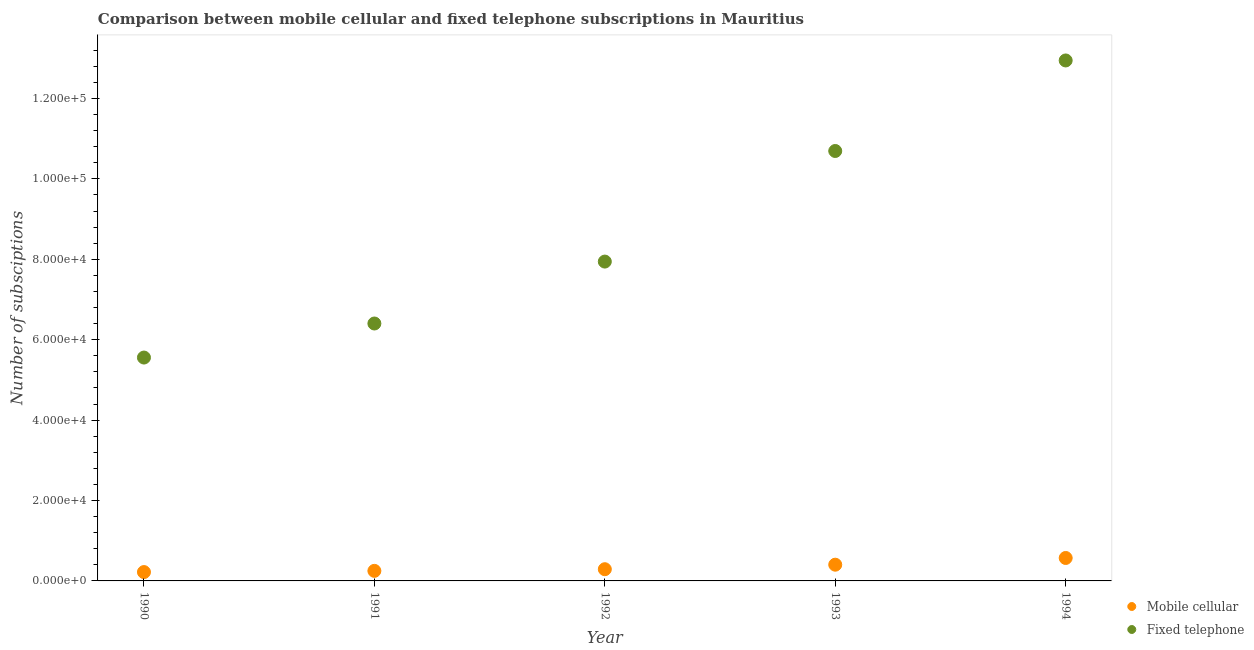How many different coloured dotlines are there?
Ensure brevity in your answer.  2. What is the number of mobile cellular subscriptions in 1993?
Provide a succinct answer. 4037. Across all years, what is the maximum number of fixed telephone subscriptions?
Your response must be concise. 1.29e+05. Across all years, what is the minimum number of fixed telephone subscriptions?
Offer a terse response. 5.56e+04. In which year was the number of fixed telephone subscriptions minimum?
Your response must be concise. 1990. What is the total number of fixed telephone subscriptions in the graph?
Make the answer very short. 4.35e+05. What is the difference between the number of fixed telephone subscriptions in 1990 and that in 1992?
Your answer should be compact. -2.39e+04. What is the difference between the number of mobile cellular subscriptions in 1993 and the number of fixed telephone subscriptions in 1991?
Ensure brevity in your answer.  -6.00e+04. What is the average number of fixed telephone subscriptions per year?
Provide a short and direct response. 8.71e+04. In the year 1993, what is the difference between the number of mobile cellular subscriptions and number of fixed telephone subscriptions?
Your answer should be compact. -1.03e+05. What is the ratio of the number of fixed telephone subscriptions in 1991 to that in 1993?
Give a very brief answer. 0.6. Is the number of fixed telephone subscriptions in 1990 less than that in 1993?
Your answer should be compact. Yes. What is the difference between the highest and the second highest number of mobile cellular subscriptions?
Give a very brief answer. 1669. What is the difference between the highest and the lowest number of mobile cellular subscriptions?
Ensure brevity in your answer.  3506. Is the sum of the number of fixed telephone subscriptions in 1992 and 1993 greater than the maximum number of mobile cellular subscriptions across all years?
Your answer should be compact. Yes. Is the number of mobile cellular subscriptions strictly greater than the number of fixed telephone subscriptions over the years?
Give a very brief answer. No. Is the number of fixed telephone subscriptions strictly less than the number of mobile cellular subscriptions over the years?
Offer a terse response. No. How many dotlines are there?
Give a very brief answer. 2. How many years are there in the graph?
Your answer should be very brief. 5. Does the graph contain grids?
Offer a very short reply. No. How many legend labels are there?
Give a very brief answer. 2. How are the legend labels stacked?
Provide a succinct answer. Vertical. What is the title of the graph?
Provide a succinct answer. Comparison between mobile cellular and fixed telephone subscriptions in Mauritius. What is the label or title of the Y-axis?
Your response must be concise. Number of subsciptions. What is the Number of subsciptions of Mobile cellular in 1990?
Ensure brevity in your answer.  2200. What is the Number of subsciptions in Fixed telephone in 1990?
Provide a succinct answer. 5.56e+04. What is the Number of subsciptions of Mobile cellular in 1991?
Offer a very short reply. 2500. What is the Number of subsciptions of Fixed telephone in 1991?
Keep it short and to the point. 6.40e+04. What is the Number of subsciptions in Mobile cellular in 1992?
Provide a succinct answer. 2912. What is the Number of subsciptions of Fixed telephone in 1992?
Your response must be concise. 7.94e+04. What is the Number of subsciptions in Mobile cellular in 1993?
Your response must be concise. 4037. What is the Number of subsciptions of Fixed telephone in 1993?
Offer a very short reply. 1.07e+05. What is the Number of subsciptions of Mobile cellular in 1994?
Your response must be concise. 5706. What is the Number of subsciptions of Fixed telephone in 1994?
Your answer should be very brief. 1.29e+05. Across all years, what is the maximum Number of subsciptions in Mobile cellular?
Keep it short and to the point. 5706. Across all years, what is the maximum Number of subsciptions in Fixed telephone?
Provide a succinct answer. 1.29e+05. Across all years, what is the minimum Number of subsciptions of Mobile cellular?
Offer a very short reply. 2200. Across all years, what is the minimum Number of subsciptions in Fixed telephone?
Make the answer very short. 5.56e+04. What is the total Number of subsciptions in Mobile cellular in the graph?
Your response must be concise. 1.74e+04. What is the total Number of subsciptions of Fixed telephone in the graph?
Offer a very short reply. 4.35e+05. What is the difference between the Number of subsciptions of Mobile cellular in 1990 and that in 1991?
Keep it short and to the point. -300. What is the difference between the Number of subsciptions in Fixed telephone in 1990 and that in 1991?
Provide a short and direct response. -8468. What is the difference between the Number of subsciptions in Mobile cellular in 1990 and that in 1992?
Offer a very short reply. -712. What is the difference between the Number of subsciptions in Fixed telephone in 1990 and that in 1992?
Your answer should be compact. -2.39e+04. What is the difference between the Number of subsciptions in Mobile cellular in 1990 and that in 1993?
Offer a very short reply. -1837. What is the difference between the Number of subsciptions in Fixed telephone in 1990 and that in 1993?
Keep it short and to the point. -5.14e+04. What is the difference between the Number of subsciptions in Mobile cellular in 1990 and that in 1994?
Keep it short and to the point. -3506. What is the difference between the Number of subsciptions of Fixed telephone in 1990 and that in 1994?
Offer a very short reply. -7.39e+04. What is the difference between the Number of subsciptions in Mobile cellular in 1991 and that in 1992?
Provide a short and direct response. -412. What is the difference between the Number of subsciptions of Fixed telephone in 1991 and that in 1992?
Your answer should be compact. -1.54e+04. What is the difference between the Number of subsciptions in Mobile cellular in 1991 and that in 1993?
Give a very brief answer. -1537. What is the difference between the Number of subsciptions in Fixed telephone in 1991 and that in 1993?
Your answer should be very brief. -4.29e+04. What is the difference between the Number of subsciptions in Mobile cellular in 1991 and that in 1994?
Your answer should be very brief. -3206. What is the difference between the Number of subsciptions of Fixed telephone in 1991 and that in 1994?
Ensure brevity in your answer.  -6.54e+04. What is the difference between the Number of subsciptions of Mobile cellular in 1992 and that in 1993?
Provide a succinct answer. -1125. What is the difference between the Number of subsciptions of Fixed telephone in 1992 and that in 1993?
Keep it short and to the point. -2.75e+04. What is the difference between the Number of subsciptions of Mobile cellular in 1992 and that in 1994?
Your answer should be very brief. -2794. What is the difference between the Number of subsciptions in Fixed telephone in 1992 and that in 1994?
Provide a short and direct response. -5.00e+04. What is the difference between the Number of subsciptions of Mobile cellular in 1993 and that in 1994?
Offer a very short reply. -1669. What is the difference between the Number of subsciptions of Fixed telephone in 1993 and that in 1994?
Provide a short and direct response. -2.25e+04. What is the difference between the Number of subsciptions of Mobile cellular in 1990 and the Number of subsciptions of Fixed telephone in 1991?
Give a very brief answer. -6.18e+04. What is the difference between the Number of subsciptions of Mobile cellular in 1990 and the Number of subsciptions of Fixed telephone in 1992?
Keep it short and to the point. -7.72e+04. What is the difference between the Number of subsciptions of Mobile cellular in 1990 and the Number of subsciptions of Fixed telephone in 1993?
Provide a succinct answer. -1.05e+05. What is the difference between the Number of subsciptions in Mobile cellular in 1990 and the Number of subsciptions in Fixed telephone in 1994?
Ensure brevity in your answer.  -1.27e+05. What is the difference between the Number of subsciptions in Mobile cellular in 1991 and the Number of subsciptions in Fixed telephone in 1992?
Give a very brief answer. -7.69e+04. What is the difference between the Number of subsciptions of Mobile cellular in 1991 and the Number of subsciptions of Fixed telephone in 1993?
Provide a succinct answer. -1.04e+05. What is the difference between the Number of subsciptions in Mobile cellular in 1991 and the Number of subsciptions in Fixed telephone in 1994?
Make the answer very short. -1.27e+05. What is the difference between the Number of subsciptions of Mobile cellular in 1992 and the Number of subsciptions of Fixed telephone in 1993?
Your response must be concise. -1.04e+05. What is the difference between the Number of subsciptions in Mobile cellular in 1992 and the Number of subsciptions in Fixed telephone in 1994?
Provide a succinct answer. -1.27e+05. What is the difference between the Number of subsciptions of Mobile cellular in 1993 and the Number of subsciptions of Fixed telephone in 1994?
Your response must be concise. -1.25e+05. What is the average Number of subsciptions of Mobile cellular per year?
Keep it short and to the point. 3471. What is the average Number of subsciptions in Fixed telephone per year?
Provide a succinct answer. 8.71e+04. In the year 1990, what is the difference between the Number of subsciptions in Mobile cellular and Number of subsciptions in Fixed telephone?
Offer a very short reply. -5.34e+04. In the year 1991, what is the difference between the Number of subsciptions in Mobile cellular and Number of subsciptions in Fixed telephone?
Your answer should be compact. -6.15e+04. In the year 1992, what is the difference between the Number of subsciptions of Mobile cellular and Number of subsciptions of Fixed telephone?
Your answer should be very brief. -7.65e+04. In the year 1993, what is the difference between the Number of subsciptions of Mobile cellular and Number of subsciptions of Fixed telephone?
Give a very brief answer. -1.03e+05. In the year 1994, what is the difference between the Number of subsciptions in Mobile cellular and Number of subsciptions in Fixed telephone?
Make the answer very short. -1.24e+05. What is the ratio of the Number of subsciptions in Mobile cellular in 1990 to that in 1991?
Your answer should be very brief. 0.88. What is the ratio of the Number of subsciptions of Fixed telephone in 1990 to that in 1991?
Your response must be concise. 0.87. What is the ratio of the Number of subsciptions in Mobile cellular in 1990 to that in 1992?
Offer a terse response. 0.76. What is the ratio of the Number of subsciptions of Fixed telephone in 1990 to that in 1992?
Make the answer very short. 0.7. What is the ratio of the Number of subsciptions of Mobile cellular in 1990 to that in 1993?
Your response must be concise. 0.55. What is the ratio of the Number of subsciptions in Fixed telephone in 1990 to that in 1993?
Keep it short and to the point. 0.52. What is the ratio of the Number of subsciptions in Mobile cellular in 1990 to that in 1994?
Offer a very short reply. 0.39. What is the ratio of the Number of subsciptions in Fixed telephone in 1990 to that in 1994?
Ensure brevity in your answer.  0.43. What is the ratio of the Number of subsciptions of Mobile cellular in 1991 to that in 1992?
Your answer should be compact. 0.86. What is the ratio of the Number of subsciptions of Fixed telephone in 1991 to that in 1992?
Provide a short and direct response. 0.81. What is the ratio of the Number of subsciptions in Mobile cellular in 1991 to that in 1993?
Your answer should be very brief. 0.62. What is the ratio of the Number of subsciptions of Fixed telephone in 1991 to that in 1993?
Make the answer very short. 0.6. What is the ratio of the Number of subsciptions of Mobile cellular in 1991 to that in 1994?
Give a very brief answer. 0.44. What is the ratio of the Number of subsciptions in Fixed telephone in 1991 to that in 1994?
Your response must be concise. 0.49. What is the ratio of the Number of subsciptions of Mobile cellular in 1992 to that in 1993?
Provide a succinct answer. 0.72. What is the ratio of the Number of subsciptions of Fixed telephone in 1992 to that in 1993?
Offer a terse response. 0.74. What is the ratio of the Number of subsciptions of Mobile cellular in 1992 to that in 1994?
Your answer should be very brief. 0.51. What is the ratio of the Number of subsciptions of Fixed telephone in 1992 to that in 1994?
Offer a terse response. 0.61. What is the ratio of the Number of subsciptions of Mobile cellular in 1993 to that in 1994?
Make the answer very short. 0.71. What is the ratio of the Number of subsciptions of Fixed telephone in 1993 to that in 1994?
Offer a very short reply. 0.83. What is the difference between the highest and the second highest Number of subsciptions in Mobile cellular?
Make the answer very short. 1669. What is the difference between the highest and the second highest Number of subsciptions of Fixed telephone?
Offer a terse response. 2.25e+04. What is the difference between the highest and the lowest Number of subsciptions in Mobile cellular?
Make the answer very short. 3506. What is the difference between the highest and the lowest Number of subsciptions in Fixed telephone?
Offer a terse response. 7.39e+04. 